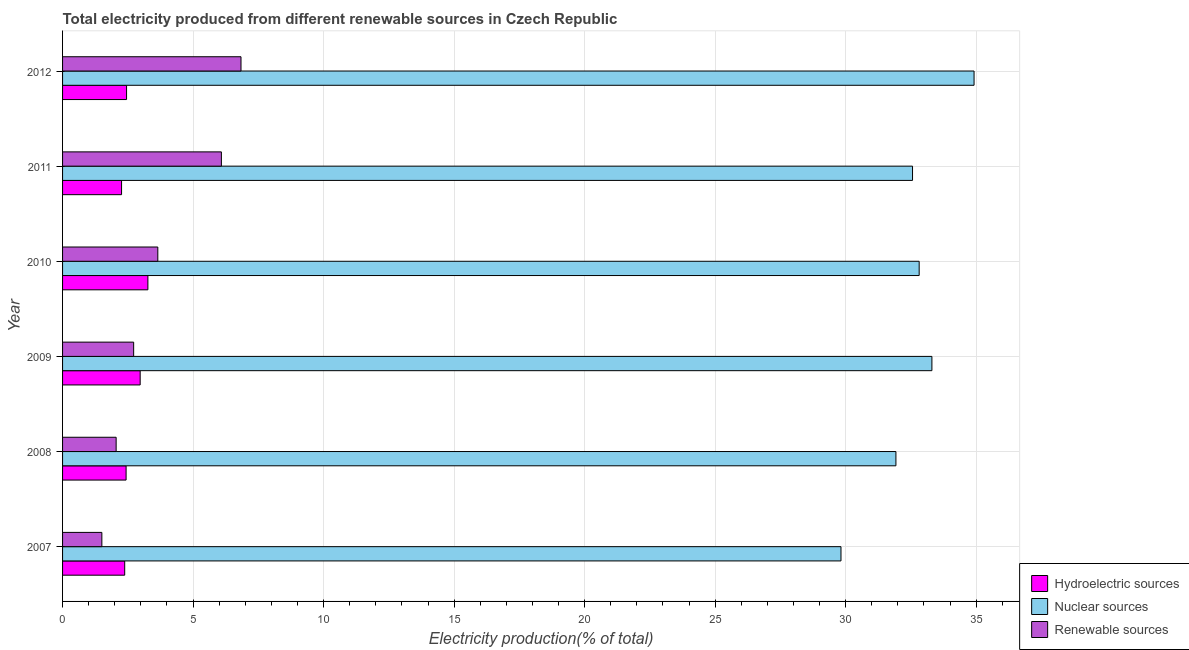How many different coloured bars are there?
Your answer should be compact. 3. How many groups of bars are there?
Give a very brief answer. 6. How many bars are there on the 5th tick from the top?
Offer a very short reply. 3. How many bars are there on the 6th tick from the bottom?
Ensure brevity in your answer.  3. In how many cases, is the number of bars for a given year not equal to the number of legend labels?
Give a very brief answer. 0. What is the percentage of electricity produced by renewable sources in 2010?
Offer a very short reply. 3.65. Across all years, what is the maximum percentage of electricity produced by hydroelectric sources?
Keep it short and to the point. 3.27. Across all years, what is the minimum percentage of electricity produced by hydroelectric sources?
Provide a short and direct response. 2.26. In which year was the percentage of electricity produced by nuclear sources maximum?
Your answer should be very brief. 2012. What is the total percentage of electricity produced by nuclear sources in the graph?
Your answer should be very brief. 195.35. What is the difference between the percentage of electricity produced by renewable sources in 2007 and that in 2010?
Keep it short and to the point. -2.14. What is the difference between the percentage of electricity produced by nuclear sources in 2007 and the percentage of electricity produced by hydroelectric sources in 2011?
Give a very brief answer. 27.56. What is the average percentage of electricity produced by hydroelectric sources per year?
Ensure brevity in your answer.  2.63. In the year 2012, what is the difference between the percentage of electricity produced by renewable sources and percentage of electricity produced by nuclear sources?
Provide a short and direct response. -28.08. In how many years, is the percentage of electricity produced by nuclear sources greater than 19 %?
Give a very brief answer. 6. Is the percentage of electricity produced by hydroelectric sources in 2007 less than that in 2008?
Make the answer very short. Yes. What is the difference between the highest and the second highest percentage of electricity produced by renewable sources?
Keep it short and to the point. 0.75. What does the 3rd bar from the top in 2009 represents?
Ensure brevity in your answer.  Hydroelectric sources. What does the 3rd bar from the bottom in 2009 represents?
Your response must be concise. Renewable sources. Is it the case that in every year, the sum of the percentage of electricity produced by hydroelectric sources and percentage of electricity produced by nuclear sources is greater than the percentage of electricity produced by renewable sources?
Your answer should be compact. Yes. How many bars are there?
Provide a short and direct response. 18. Are all the bars in the graph horizontal?
Your answer should be very brief. Yes. What is the difference between two consecutive major ticks on the X-axis?
Offer a terse response. 5. Does the graph contain any zero values?
Your answer should be very brief. No. What is the title of the graph?
Your answer should be very brief. Total electricity produced from different renewable sources in Czech Republic. What is the Electricity production(% of total) of Hydroelectric sources in 2007?
Ensure brevity in your answer.  2.38. What is the Electricity production(% of total) of Nuclear sources in 2007?
Offer a terse response. 29.82. What is the Electricity production(% of total) of Renewable sources in 2007?
Your answer should be compact. 1.51. What is the Electricity production(% of total) of Hydroelectric sources in 2008?
Your answer should be compact. 2.43. What is the Electricity production(% of total) of Nuclear sources in 2008?
Offer a very short reply. 31.93. What is the Electricity production(% of total) of Renewable sources in 2008?
Give a very brief answer. 2.05. What is the Electricity production(% of total) in Hydroelectric sources in 2009?
Provide a succinct answer. 2.97. What is the Electricity production(% of total) in Nuclear sources in 2009?
Keep it short and to the point. 33.3. What is the Electricity production(% of total) of Renewable sources in 2009?
Provide a succinct answer. 2.72. What is the Electricity production(% of total) in Hydroelectric sources in 2010?
Ensure brevity in your answer.  3.27. What is the Electricity production(% of total) in Nuclear sources in 2010?
Give a very brief answer. 32.82. What is the Electricity production(% of total) in Renewable sources in 2010?
Make the answer very short. 3.65. What is the Electricity production(% of total) in Hydroelectric sources in 2011?
Provide a succinct answer. 2.26. What is the Electricity production(% of total) of Nuclear sources in 2011?
Offer a very short reply. 32.56. What is the Electricity production(% of total) in Renewable sources in 2011?
Your answer should be compact. 6.08. What is the Electricity production(% of total) in Hydroelectric sources in 2012?
Offer a terse response. 2.45. What is the Electricity production(% of total) of Nuclear sources in 2012?
Give a very brief answer. 34.92. What is the Electricity production(% of total) of Renewable sources in 2012?
Provide a short and direct response. 6.84. Across all years, what is the maximum Electricity production(% of total) of Hydroelectric sources?
Make the answer very short. 3.27. Across all years, what is the maximum Electricity production(% of total) of Nuclear sources?
Offer a very short reply. 34.92. Across all years, what is the maximum Electricity production(% of total) in Renewable sources?
Offer a terse response. 6.84. Across all years, what is the minimum Electricity production(% of total) in Hydroelectric sources?
Offer a very short reply. 2.26. Across all years, what is the minimum Electricity production(% of total) of Nuclear sources?
Your answer should be very brief. 29.82. Across all years, what is the minimum Electricity production(% of total) of Renewable sources?
Provide a succinct answer. 1.51. What is the total Electricity production(% of total) of Hydroelectric sources in the graph?
Give a very brief answer. 15.77. What is the total Electricity production(% of total) in Nuclear sources in the graph?
Offer a terse response. 195.35. What is the total Electricity production(% of total) in Renewable sources in the graph?
Provide a succinct answer. 22.85. What is the difference between the Electricity production(% of total) in Hydroelectric sources in 2007 and that in 2008?
Offer a very short reply. -0.05. What is the difference between the Electricity production(% of total) of Nuclear sources in 2007 and that in 2008?
Offer a very short reply. -2.1. What is the difference between the Electricity production(% of total) of Renewable sources in 2007 and that in 2008?
Offer a very short reply. -0.55. What is the difference between the Electricity production(% of total) of Hydroelectric sources in 2007 and that in 2009?
Your answer should be compact. -0.59. What is the difference between the Electricity production(% of total) in Nuclear sources in 2007 and that in 2009?
Give a very brief answer. -3.48. What is the difference between the Electricity production(% of total) in Renewable sources in 2007 and that in 2009?
Offer a very short reply. -1.22. What is the difference between the Electricity production(% of total) in Hydroelectric sources in 2007 and that in 2010?
Keep it short and to the point. -0.89. What is the difference between the Electricity production(% of total) in Nuclear sources in 2007 and that in 2010?
Your response must be concise. -2.99. What is the difference between the Electricity production(% of total) in Renewable sources in 2007 and that in 2010?
Offer a very short reply. -2.14. What is the difference between the Electricity production(% of total) in Hydroelectric sources in 2007 and that in 2011?
Give a very brief answer. 0.12. What is the difference between the Electricity production(% of total) of Nuclear sources in 2007 and that in 2011?
Keep it short and to the point. -2.74. What is the difference between the Electricity production(% of total) in Renewable sources in 2007 and that in 2011?
Your answer should be very brief. -4.58. What is the difference between the Electricity production(% of total) of Hydroelectric sources in 2007 and that in 2012?
Your response must be concise. -0.07. What is the difference between the Electricity production(% of total) in Nuclear sources in 2007 and that in 2012?
Provide a short and direct response. -5.1. What is the difference between the Electricity production(% of total) of Renewable sources in 2007 and that in 2012?
Your answer should be compact. -5.33. What is the difference between the Electricity production(% of total) in Hydroelectric sources in 2008 and that in 2009?
Offer a terse response. -0.54. What is the difference between the Electricity production(% of total) in Nuclear sources in 2008 and that in 2009?
Offer a terse response. -1.38. What is the difference between the Electricity production(% of total) of Renewable sources in 2008 and that in 2009?
Ensure brevity in your answer.  -0.67. What is the difference between the Electricity production(% of total) of Hydroelectric sources in 2008 and that in 2010?
Ensure brevity in your answer.  -0.84. What is the difference between the Electricity production(% of total) in Nuclear sources in 2008 and that in 2010?
Make the answer very short. -0.89. What is the difference between the Electricity production(% of total) of Renewable sources in 2008 and that in 2010?
Keep it short and to the point. -1.6. What is the difference between the Electricity production(% of total) of Hydroelectric sources in 2008 and that in 2011?
Your answer should be very brief. 0.17. What is the difference between the Electricity production(% of total) of Nuclear sources in 2008 and that in 2011?
Offer a very short reply. -0.64. What is the difference between the Electricity production(% of total) of Renewable sources in 2008 and that in 2011?
Your answer should be very brief. -4.03. What is the difference between the Electricity production(% of total) in Hydroelectric sources in 2008 and that in 2012?
Provide a short and direct response. -0.02. What is the difference between the Electricity production(% of total) of Nuclear sources in 2008 and that in 2012?
Ensure brevity in your answer.  -2.99. What is the difference between the Electricity production(% of total) in Renewable sources in 2008 and that in 2012?
Give a very brief answer. -4.78. What is the difference between the Electricity production(% of total) of Hydroelectric sources in 2009 and that in 2010?
Your response must be concise. -0.3. What is the difference between the Electricity production(% of total) of Nuclear sources in 2009 and that in 2010?
Provide a short and direct response. 0.49. What is the difference between the Electricity production(% of total) of Renewable sources in 2009 and that in 2010?
Provide a short and direct response. -0.93. What is the difference between the Electricity production(% of total) in Hydroelectric sources in 2009 and that in 2011?
Provide a short and direct response. 0.71. What is the difference between the Electricity production(% of total) in Nuclear sources in 2009 and that in 2011?
Make the answer very short. 0.74. What is the difference between the Electricity production(% of total) of Renewable sources in 2009 and that in 2011?
Your answer should be very brief. -3.36. What is the difference between the Electricity production(% of total) of Hydroelectric sources in 2009 and that in 2012?
Provide a succinct answer. 0.52. What is the difference between the Electricity production(% of total) in Nuclear sources in 2009 and that in 2012?
Ensure brevity in your answer.  -1.61. What is the difference between the Electricity production(% of total) in Renewable sources in 2009 and that in 2012?
Keep it short and to the point. -4.11. What is the difference between the Electricity production(% of total) in Hydroelectric sources in 2010 and that in 2011?
Give a very brief answer. 1.01. What is the difference between the Electricity production(% of total) in Nuclear sources in 2010 and that in 2011?
Give a very brief answer. 0.25. What is the difference between the Electricity production(% of total) in Renewable sources in 2010 and that in 2011?
Make the answer very short. -2.44. What is the difference between the Electricity production(% of total) of Hydroelectric sources in 2010 and that in 2012?
Keep it short and to the point. 0.82. What is the difference between the Electricity production(% of total) of Nuclear sources in 2010 and that in 2012?
Ensure brevity in your answer.  -2.1. What is the difference between the Electricity production(% of total) in Renewable sources in 2010 and that in 2012?
Provide a short and direct response. -3.19. What is the difference between the Electricity production(% of total) in Hydroelectric sources in 2011 and that in 2012?
Ensure brevity in your answer.  -0.19. What is the difference between the Electricity production(% of total) of Nuclear sources in 2011 and that in 2012?
Keep it short and to the point. -2.36. What is the difference between the Electricity production(% of total) in Renewable sources in 2011 and that in 2012?
Give a very brief answer. -0.75. What is the difference between the Electricity production(% of total) of Hydroelectric sources in 2007 and the Electricity production(% of total) of Nuclear sources in 2008?
Your response must be concise. -29.55. What is the difference between the Electricity production(% of total) in Hydroelectric sources in 2007 and the Electricity production(% of total) in Renewable sources in 2008?
Provide a succinct answer. 0.33. What is the difference between the Electricity production(% of total) in Nuclear sources in 2007 and the Electricity production(% of total) in Renewable sources in 2008?
Give a very brief answer. 27.77. What is the difference between the Electricity production(% of total) of Hydroelectric sources in 2007 and the Electricity production(% of total) of Nuclear sources in 2009?
Make the answer very short. -30.92. What is the difference between the Electricity production(% of total) of Hydroelectric sources in 2007 and the Electricity production(% of total) of Renewable sources in 2009?
Provide a succinct answer. -0.34. What is the difference between the Electricity production(% of total) in Nuclear sources in 2007 and the Electricity production(% of total) in Renewable sources in 2009?
Make the answer very short. 27.1. What is the difference between the Electricity production(% of total) in Hydroelectric sources in 2007 and the Electricity production(% of total) in Nuclear sources in 2010?
Your response must be concise. -30.44. What is the difference between the Electricity production(% of total) in Hydroelectric sources in 2007 and the Electricity production(% of total) in Renewable sources in 2010?
Keep it short and to the point. -1.27. What is the difference between the Electricity production(% of total) of Nuclear sources in 2007 and the Electricity production(% of total) of Renewable sources in 2010?
Your answer should be very brief. 26.17. What is the difference between the Electricity production(% of total) of Hydroelectric sources in 2007 and the Electricity production(% of total) of Nuclear sources in 2011?
Offer a terse response. -30.18. What is the difference between the Electricity production(% of total) in Hydroelectric sources in 2007 and the Electricity production(% of total) in Renewable sources in 2011?
Your answer should be very brief. -3.7. What is the difference between the Electricity production(% of total) of Nuclear sources in 2007 and the Electricity production(% of total) of Renewable sources in 2011?
Your answer should be compact. 23.74. What is the difference between the Electricity production(% of total) of Hydroelectric sources in 2007 and the Electricity production(% of total) of Nuclear sources in 2012?
Offer a very short reply. -32.54. What is the difference between the Electricity production(% of total) of Hydroelectric sources in 2007 and the Electricity production(% of total) of Renewable sources in 2012?
Give a very brief answer. -4.46. What is the difference between the Electricity production(% of total) of Nuclear sources in 2007 and the Electricity production(% of total) of Renewable sources in 2012?
Ensure brevity in your answer.  22.99. What is the difference between the Electricity production(% of total) in Hydroelectric sources in 2008 and the Electricity production(% of total) in Nuclear sources in 2009?
Your answer should be very brief. -30.87. What is the difference between the Electricity production(% of total) of Hydroelectric sources in 2008 and the Electricity production(% of total) of Renewable sources in 2009?
Your answer should be compact. -0.29. What is the difference between the Electricity production(% of total) of Nuclear sources in 2008 and the Electricity production(% of total) of Renewable sources in 2009?
Make the answer very short. 29.2. What is the difference between the Electricity production(% of total) in Hydroelectric sources in 2008 and the Electricity production(% of total) in Nuclear sources in 2010?
Offer a terse response. -30.38. What is the difference between the Electricity production(% of total) of Hydroelectric sources in 2008 and the Electricity production(% of total) of Renewable sources in 2010?
Keep it short and to the point. -1.22. What is the difference between the Electricity production(% of total) in Nuclear sources in 2008 and the Electricity production(% of total) in Renewable sources in 2010?
Give a very brief answer. 28.28. What is the difference between the Electricity production(% of total) in Hydroelectric sources in 2008 and the Electricity production(% of total) in Nuclear sources in 2011?
Provide a succinct answer. -30.13. What is the difference between the Electricity production(% of total) in Hydroelectric sources in 2008 and the Electricity production(% of total) in Renewable sources in 2011?
Your answer should be very brief. -3.65. What is the difference between the Electricity production(% of total) in Nuclear sources in 2008 and the Electricity production(% of total) in Renewable sources in 2011?
Your response must be concise. 25.84. What is the difference between the Electricity production(% of total) of Hydroelectric sources in 2008 and the Electricity production(% of total) of Nuclear sources in 2012?
Your answer should be compact. -32.48. What is the difference between the Electricity production(% of total) in Hydroelectric sources in 2008 and the Electricity production(% of total) in Renewable sources in 2012?
Your response must be concise. -4.4. What is the difference between the Electricity production(% of total) of Nuclear sources in 2008 and the Electricity production(% of total) of Renewable sources in 2012?
Make the answer very short. 25.09. What is the difference between the Electricity production(% of total) of Hydroelectric sources in 2009 and the Electricity production(% of total) of Nuclear sources in 2010?
Your response must be concise. -29.84. What is the difference between the Electricity production(% of total) of Hydroelectric sources in 2009 and the Electricity production(% of total) of Renewable sources in 2010?
Offer a very short reply. -0.68. What is the difference between the Electricity production(% of total) of Nuclear sources in 2009 and the Electricity production(% of total) of Renewable sources in 2010?
Your answer should be very brief. 29.65. What is the difference between the Electricity production(% of total) of Hydroelectric sources in 2009 and the Electricity production(% of total) of Nuclear sources in 2011?
Your answer should be compact. -29.59. What is the difference between the Electricity production(% of total) in Hydroelectric sources in 2009 and the Electricity production(% of total) in Renewable sources in 2011?
Offer a terse response. -3.11. What is the difference between the Electricity production(% of total) of Nuclear sources in 2009 and the Electricity production(% of total) of Renewable sources in 2011?
Keep it short and to the point. 27.22. What is the difference between the Electricity production(% of total) in Hydroelectric sources in 2009 and the Electricity production(% of total) in Nuclear sources in 2012?
Offer a terse response. -31.95. What is the difference between the Electricity production(% of total) in Hydroelectric sources in 2009 and the Electricity production(% of total) in Renewable sources in 2012?
Provide a succinct answer. -3.86. What is the difference between the Electricity production(% of total) in Nuclear sources in 2009 and the Electricity production(% of total) in Renewable sources in 2012?
Provide a succinct answer. 26.47. What is the difference between the Electricity production(% of total) in Hydroelectric sources in 2010 and the Electricity production(% of total) in Nuclear sources in 2011?
Offer a terse response. -29.29. What is the difference between the Electricity production(% of total) in Hydroelectric sources in 2010 and the Electricity production(% of total) in Renewable sources in 2011?
Provide a short and direct response. -2.82. What is the difference between the Electricity production(% of total) in Nuclear sources in 2010 and the Electricity production(% of total) in Renewable sources in 2011?
Make the answer very short. 26.73. What is the difference between the Electricity production(% of total) of Hydroelectric sources in 2010 and the Electricity production(% of total) of Nuclear sources in 2012?
Offer a very short reply. -31.65. What is the difference between the Electricity production(% of total) of Hydroelectric sources in 2010 and the Electricity production(% of total) of Renewable sources in 2012?
Keep it short and to the point. -3.57. What is the difference between the Electricity production(% of total) in Nuclear sources in 2010 and the Electricity production(% of total) in Renewable sources in 2012?
Offer a very short reply. 25.98. What is the difference between the Electricity production(% of total) in Hydroelectric sources in 2011 and the Electricity production(% of total) in Nuclear sources in 2012?
Your answer should be very brief. -32.66. What is the difference between the Electricity production(% of total) of Hydroelectric sources in 2011 and the Electricity production(% of total) of Renewable sources in 2012?
Offer a terse response. -4.58. What is the difference between the Electricity production(% of total) in Nuclear sources in 2011 and the Electricity production(% of total) in Renewable sources in 2012?
Offer a very short reply. 25.73. What is the average Electricity production(% of total) of Hydroelectric sources per year?
Provide a succinct answer. 2.63. What is the average Electricity production(% of total) in Nuclear sources per year?
Your answer should be very brief. 32.56. What is the average Electricity production(% of total) in Renewable sources per year?
Offer a very short reply. 3.81. In the year 2007, what is the difference between the Electricity production(% of total) of Hydroelectric sources and Electricity production(% of total) of Nuclear sources?
Your response must be concise. -27.44. In the year 2007, what is the difference between the Electricity production(% of total) of Hydroelectric sources and Electricity production(% of total) of Renewable sources?
Offer a very short reply. 0.88. In the year 2007, what is the difference between the Electricity production(% of total) in Nuclear sources and Electricity production(% of total) in Renewable sources?
Your response must be concise. 28.32. In the year 2008, what is the difference between the Electricity production(% of total) in Hydroelectric sources and Electricity production(% of total) in Nuclear sources?
Your response must be concise. -29.49. In the year 2008, what is the difference between the Electricity production(% of total) of Hydroelectric sources and Electricity production(% of total) of Renewable sources?
Give a very brief answer. 0.38. In the year 2008, what is the difference between the Electricity production(% of total) of Nuclear sources and Electricity production(% of total) of Renewable sources?
Offer a terse response. 29.87. In the year 2009, what is the difference between the Electricity production(% of total) of Hydroelectric sources and Electricity production(% of total) of Nuclear sources?
Your answer should be very brief. -30.33. In the year 2009, what is the difference between the Electricity production(% of total) in Hydroelectric sources and Electricity production(% of total) in Renewable sources?
Offer a terse response. 0.25. In the year 2009, what is the difference between the Electricity production(% of total) of Nuclear sources and Electricity production(% of total) of Renewable sources?
Keep it short and to the point. 30.58. In the year 2010, what is the difference between the Electricity production(% of total) of Hydroelectric sources and Electricity production(% of total) of Nuclear sources?
Your answer should be compact. -29.55. In the year 2010, what is the difference between the Electricity production(% of total) of Hydroelectric sources and Electricity production(% of total) of Renewable sources?
Give a very brief answer. -0.38. In the year 2010, what is the difference between the Electricity production(% of total) in Nuclear sources and Electricity production(% of total) in Renewable sources?
Your response must be concise. 29.17. In the year 2011, what is the difference between the Electricity production(% of total) in Hydroelectric sources and Electricity production(% of total) in Nuclear sources?
Your answer should be compact. -30.3. In the year 2011, what is the difference between the Electricity production(% of total) in Hydroelectric sources and Electricity production(% of total) in Renewable sources?
Ensure brevity in your answer.  -3.82. In the year 2011, what is the difference between the Electricity production(% of total) of Nuclear sources and Electricity production(% of total) of Renewable sources?
Keep it short and to the point. 26.48. In the year 2012, what is the difference between the Electricity production(% of total) of Hydroelectric sources and Electricity production(% of total) of Nuclear sources?
Ensure brevity in your answer.  -32.47. In the year 2012, what is the difference between the Electricity production(% of total) in Hydroelectric sources and Electricity production(% of total) in Renewable sources?
Make the answer very short. -4.38. In the year 2012, what is the difference between the Electricity production(% of total) of Nuclear sources and Electricity production(% of total) of Renewable sources?
Ensure brevity in your answer.  28.08. What is the ratio of the Electricity production(% of total) of Hydroelectric sources in 2007 to that in 2008?
Your answer should be very brief. 0.98. What is the ratio of the Electricity production(% of total) in Nuclear sources in 2007 to that in 2008?
Offer a very short reply. 0.93. What is the ratio of the Electricity production(% of total) in Renewable sources in 2007 to that in 2008?
Your answer should be compact. 0.73. What is the ratio of the Electricity production(% of total) in Hydroelectric sources in 2007 to that in 2009?
Provide a succinct answer. 0.8. What is the ratio of the Electricity production(% of total) of Nuclear sources in 2007 to that in 2009?
Make the answer very short. 0.9. What is the ratio of the Electricity production(% of total) in Renewable sources in 2007 to that in 2009?
Your response must be concise. 0.55. What is the ratio of the Electricity production(% of total) in Hydroelectric sources in 2007 to that in 2010?
Provide a succinct answer. 0.73. What is the ratio of the Electricity production(% of total) in Nuclear sources in 2007 to that in 2010?
Ensure brevity in your answer.  0.91. What is the ratio of the Electricity production(% of total) of Renewable sources in 2007 to that in 2010?
Keep it short and to the point. 0.41. What is the ratio of the Electricity production(% of total) in Hydroelectric sources in 2007 to that in 2011?
Provide a short and direct response. 1.05. What is the ratio of the Electricity production(% of total) of Nuclear sources in 2007 to that in 2011?
Make the answer very short. 0.92. What is the ratio of the Electricity production(% of total) of Renewable sources in 2007 to that in 2011?
Offer a very short reply. 0.25. What is the ratio of the Electricity production(% of total) of Hydroelectric sources in 2007 to that in 2012?
Ensure brevity in your answer.  0.97. What is the ratio of the Electricity production(% of total) of Nuclear sources in 2007 to that in 2012?
Provide a succinct answer. 0.85. What is the ratio of the Electricity production(% of total) of Renewable sources in 2007 to that in 2012?
Your answer should be compact. 0.22. What is the ratio of the Electricity production(% of total) in Hydroelectric sources in 2008 to that in 2009?
Offer a very short reply. 0.82. What is the ratio of the Electricity production(% of total) of Nuclear sources in 2008 to that in 2009?
Your answer should be compact. 0.96. What is the ratio of the Electricity production(% of total) in Renewable sources in 2008 to that in 2009?
Offer a terse response. 0.75. What is the ratio of the Electricity production(% of total) in Hydroelectric sources in 2008 to that in 2010?
Keep it short and to the point. 0.74. What is the ratio of the Electricity production(% of total) of Nuclear sources in 2008 to that in 2010?
Give a very brief answer. 0.97. What is the ratio of the Electricity production(% of total) in Renewable sources in 2008 to that in 2010?
Make the answer very short. 0.56. What is the ratio of the Electricity production(% of total) of Nuclear sources in 2008 to that in 2011?
Ensure brevity in your answer.  0.98. What is the ratio of the Electricity production(% of total) in Renewable sources in 2008 to that in 2011?
Offer a very short reply. 0.34. What is the ratio of the Electricity production(% of total) of Hydroelectric sources in 2008 to that in 2012?
Give a very brief answer. 0.99. What is the ratio of the Electricity production(% of total) in Nuclear sources in 2008 to that in 2012?
Keep it short and to the point. 0.91. What is the ratio of the Electricity production(% of total) of Renewable sources in 2008 to that in 2012?
Provide a short and direct response. 0.3. What is the ratio of the Electricity production(% of total) in Hydroelectric sources in 2009 to that in 2010?
Provide a short and direct response. 0.91. What is the ratio of the Electricity production(% of total) in Nuclear sources in 2009 to that in 2010?
Keep it short and to the point. 1.01. What is the ratio of the Electricity production(% of total) in Renewable sources in 2009 to that in 2010?
Your answer should be compact. 0.75. What is the ratio of the Electricity production(% of total) in Hydroelectric sources in 2009 to that in 2011?
Your response must be concise. 1.32. What is the ratio of the Electricity production(% of total) of Nuclear sources in 2009 to that in 2011?
Keep it short and to the point. 1.02. What is the ratio of the Electricity production(% of total) of Renewable sources in 2009 to that in 2011?
Your answer should be very brief. 0.45. What is the ratio of the Electricity production(% of total) of Hydroelectric sources in 2009 to that in 2012?
Offer a terse response. 1.21. What is the ratio of the Electricity production(% of total) of Nuclear sources in 2009 to that in 2012?
Provide a succinct answer. 0.95. What is the ratio of the Electricity production(% of total) in Renewable sources in 2009 to that in 2012?
Your answer should be very brief. 0.4. What is the ratio of the Electricity production(% of total) of Hydroelectric sources in 2010 to that in 2011?
Your answer should be compact. 1.45. What is the ratio of the Electricity production(% of total) of Nuclear sources in 2010 to that in 2011?
Ensure brevity in your answer.  1.01. What is the ratio of the Electricity production(% of total) of Renewable sources in 2010 to that in 2011?
Give a very brief answer. 0.6. What is the ratio of the Electricity production(% of total) of Hydroelectric sources in 2010 to that in 2012?
Your response must be concise. 1.33. What is the ratio of the Electricity production(% of total) in Nuclear sources in 2010 to that in 2012?
Your answer should be compact. 0.94. What is the ratio of the Electricity production(% of total) of Renewable sources in 2010 to that in 2012?
Give a very brief answer. 0.53. What is the ratio of the Electricity production(% of total) of Hydroelectric sources in 2011 to that in 2012?
Ensure brevity in your answer.  0.92. What is the ratio of the Electricity production(% of total) in Nuclear sources in 2011 to that in 2012?
Keep it short and to the point. 0.93. What is the ratio of the Electricity production(% of total) of Renewable sources in 2011 to that in 2012?
Your answer should be compact. 0.89. What is the difference between the highest and the second highest Electricity production(% of total) of Hydroelectric sources?
Your response must be concise. 0.3. What is the difference between the highest and the second highest Electricity production(% of total) of Nuclear sources?
Ensure brevity in your answer.  1.61. What is the difference between the highest and the second highest Electricity production(% of total) of Renewable sources?
Offer a terse response. 0.75. What is the difference between the highest and the lowest Electricity production(% of total) of Hydroelectric sources?
Your response must be concise. 1.01. What is the difference between the highest and the lowest Electricity production(% of total) of Nuclear sources?
Offer a terse response. 5.1. What is the difference between the highest and the lowest Electricity production(% of total) of Renewable sources?
Give a very brief answer. 5.33. 